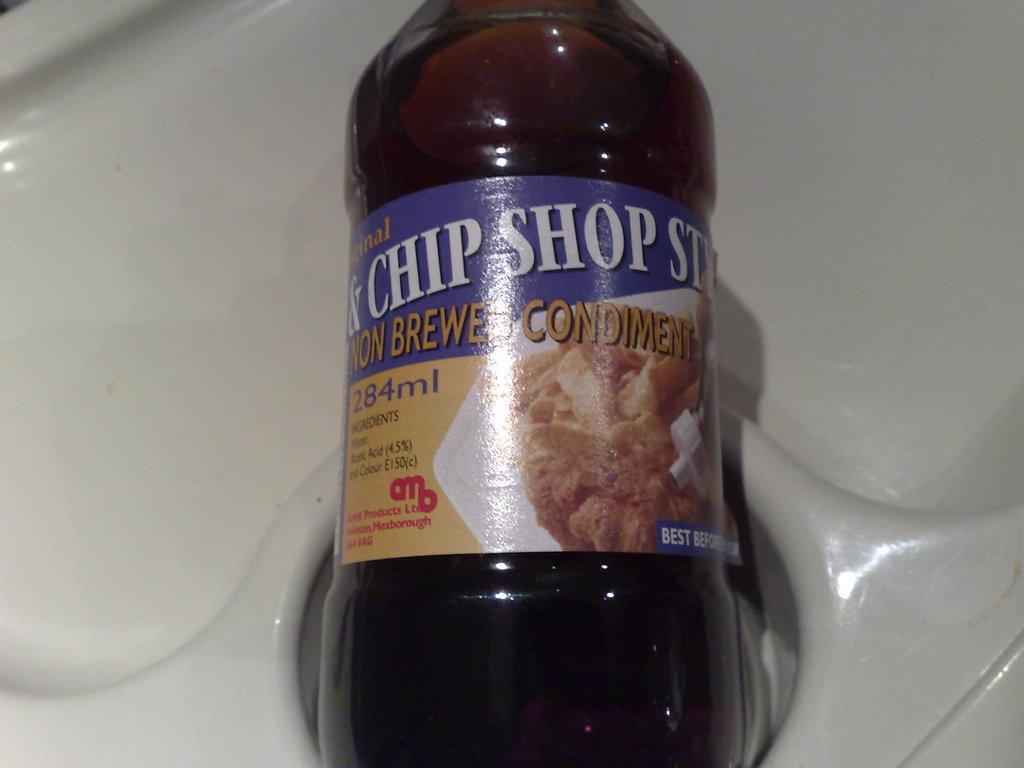What word is next to chip at the top?
Offer a terse response. Shop. 